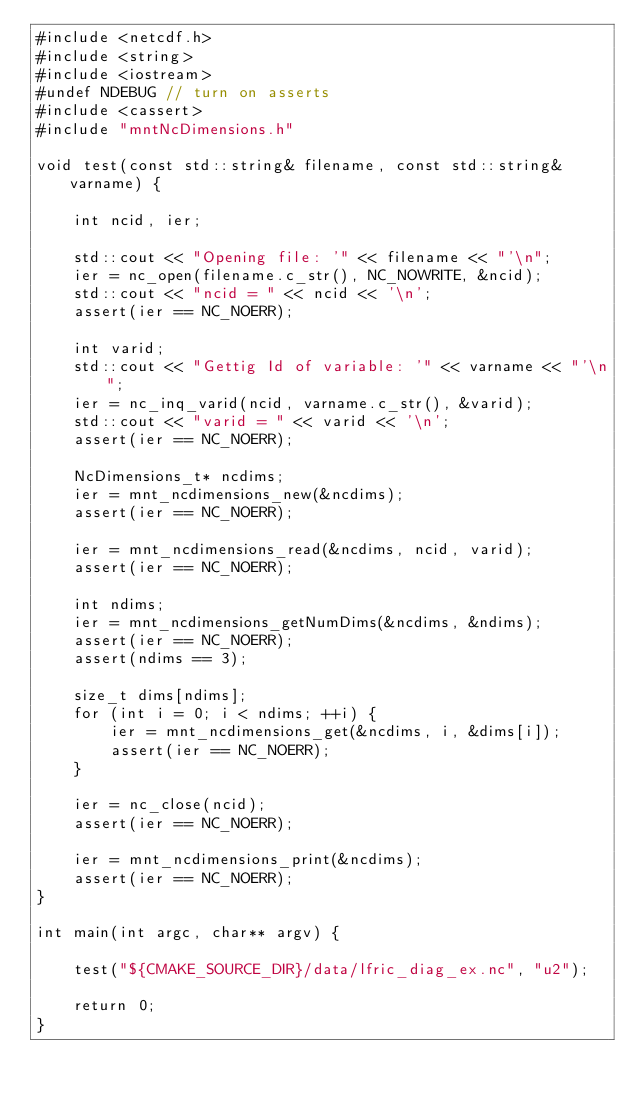<code> <loc_0><loc_0><loc_500><loc_500><_C++_>#include <netcdf.h>
#include <string>
#include <iostream>
#undef NDEBUG // turn on asserts
#include <cassert>
#include "mntNcDimensions.h"

void test(const std::string& filename, const std::string& varname) {

	int ncid, ier;

	std::cout << "Opening file: '" << filename << "'\n";
    ier = nc_open(filename.c_str(), NC_NOWRITE, &ncid);
    std::cout << "ncid = " << ncid << '\n';
    assert(ier == NC_NOERR);

    int varid;
	std::cout << "Gettig Id of variable: '" << varname << "'\n";
    ier = nc_inq_varid(ncid, varname.c_str(), &varid);
    std::cout << "varid = " << varid << '\n';
    assert(ier == NC_NOERR);

    NcDimensions_t* ncdims;
    ier = mnt_ncdimensions_new(&ncdims);
    assert(ier == NC_NOERR);

    ier = mnt_ncdimensions_read(&ncdims, ncid, varid);
    assert(ier == NC_NOERR);

    int ndims;
    ier = mnt_ncdimensions_getNumDims(&ncdims, &ndims);
    assert(ier == NC_NOERR);
    assert(ndims == 3);

    size_t dims[ndims];
    for (int i = 0; i < ndims; ++i) {
        ier = mnt_ncdimensions_get(&ncdims, i, &dims[i]);
        assert(ier == NC_NOERR);
    }

    ier = nc_close(ncid);
    assert(ier == NC_NOERR);

    ier = mnt_ncdimensions_print(&ncdims);
    assert(ier == NC_NOERR);
}

int main(int argc, char** argv) {

	test("${CMAKE_SOURCE_DIR}/data/lfric_diag_ex.nc", "u2");

    return 0;
}
</code> 